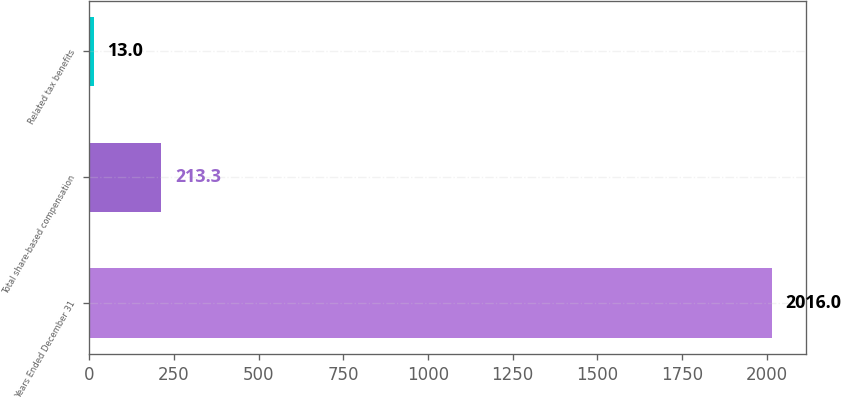<chart> <loc_0><loc_0><loc_500><loc_500><bar_chart><fcel>Years Ended December 31<fcel>Total share-based compensation<fcel>Related tax benefits<nl><fcel>2016<fcel>213.3<fcel>13<nl></chart> 